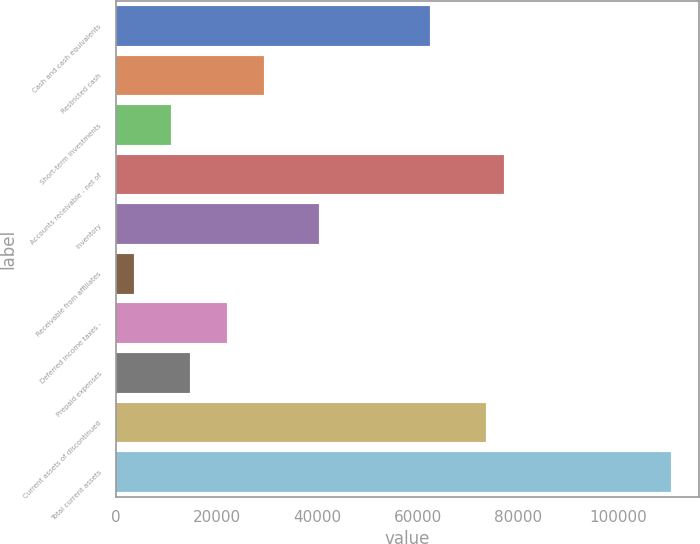<chart> <loc_0><loc_0><loc_500><loc_500><bar_chart><fcel>Cash and cash equivalents<fcel>Restricted cash<fcel>Short-term investments<fcel>Accounts receivable - net of<fcel>Inventory<fcel>Receivable from affiliates<fcel>Deferred income taxes -<fcel>Prepaid expenses<fcel>Current assets of discontinued<fcel>Total current assets<nl><fcel>62576.9<fcel>29450.6<fcel>11047.1<fcel>77299.7<fcel>40492.7<fcel>3685.7<fcel>22089.2<fcel>14727.8<fcel>73619<fcel>110426<nl></chart> 